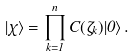<formula> <loc_0><loc_0><loc_500><loc_500>| \chi \rangle = \prod _ { k = 1 } ^ { n } C ( \zeta _ { k } ) | 0 \rangle \, .</formula> 